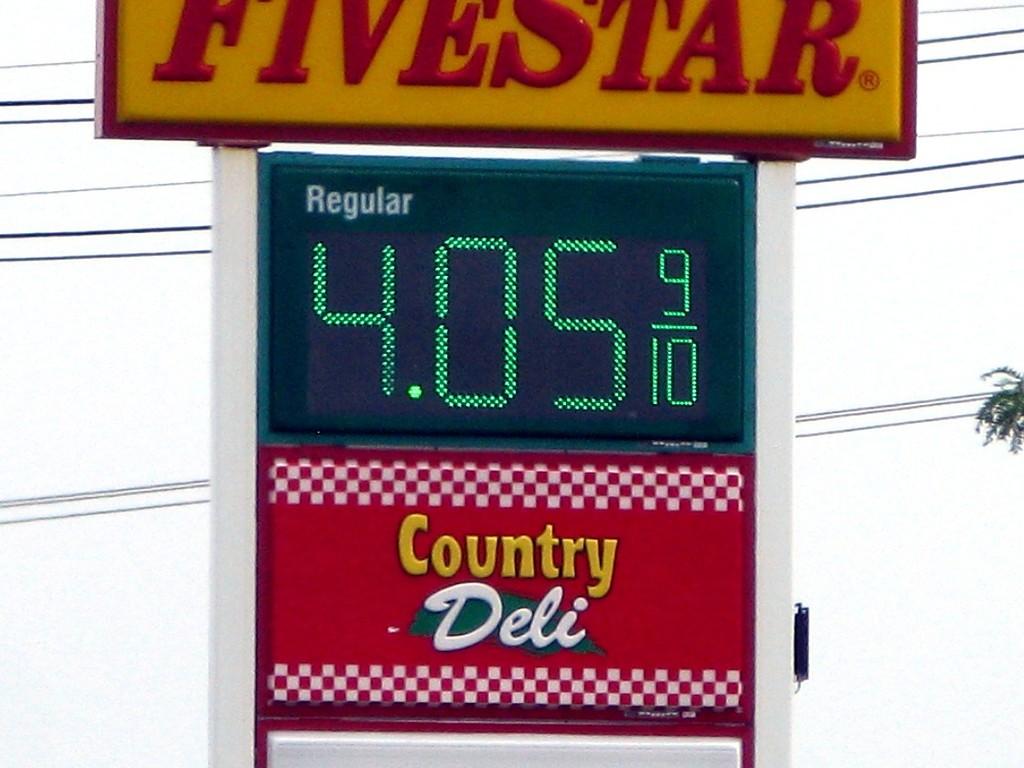How much does regular gas cost?
Your answer should be compact. 4.05. 